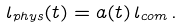<formula> <loc_0><loc_0><loc_500><loc_500>l _ { p h y s } ( t ) = a ( t ) \, l _ { c o m } \, .</formula> 